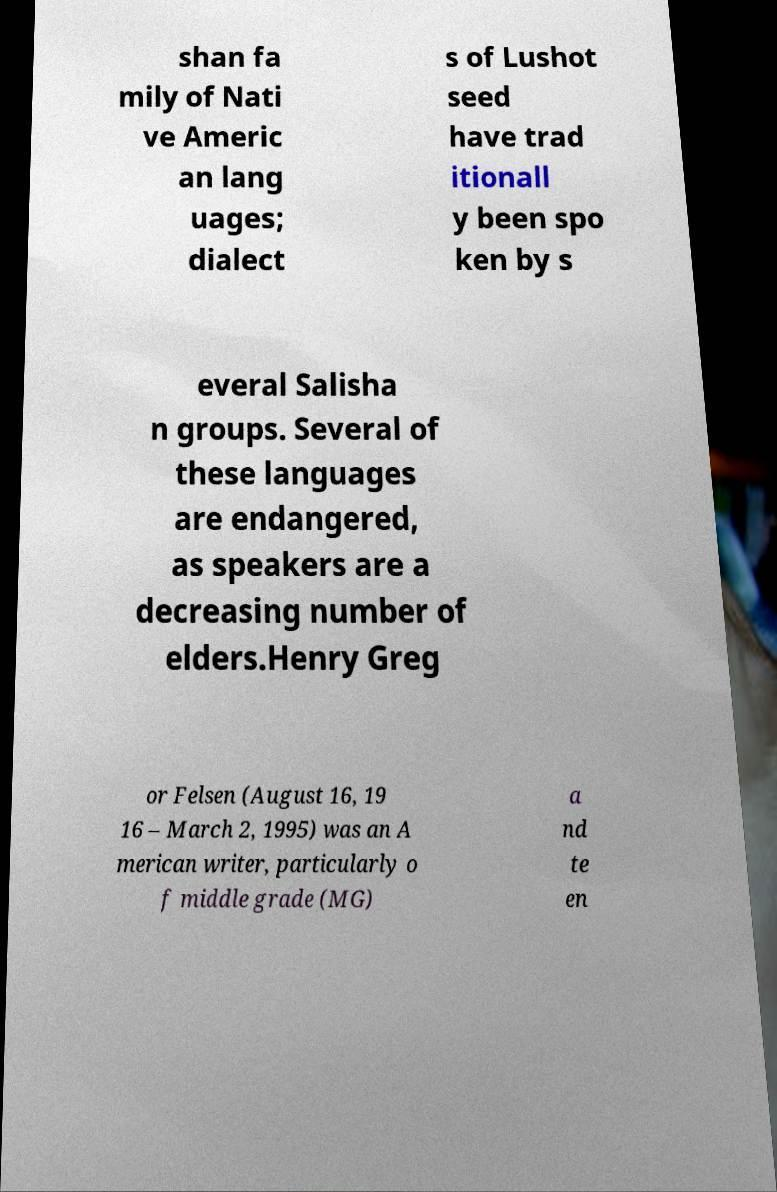Please identify and transcribe the text found in this image. shan fa mily of Nati ve Americ an lang uages; dialect s of Lushot seed have trad itionall y been spo ken by s everal Salisha n groups. Several of these languages are endangered, as speakers are a decreasing number of elders.Henry Greg or Felsen (August 16, 19 16 – March 2, 1995) was an A merican writer, particularly o f middle grade (MG) a nd te en 